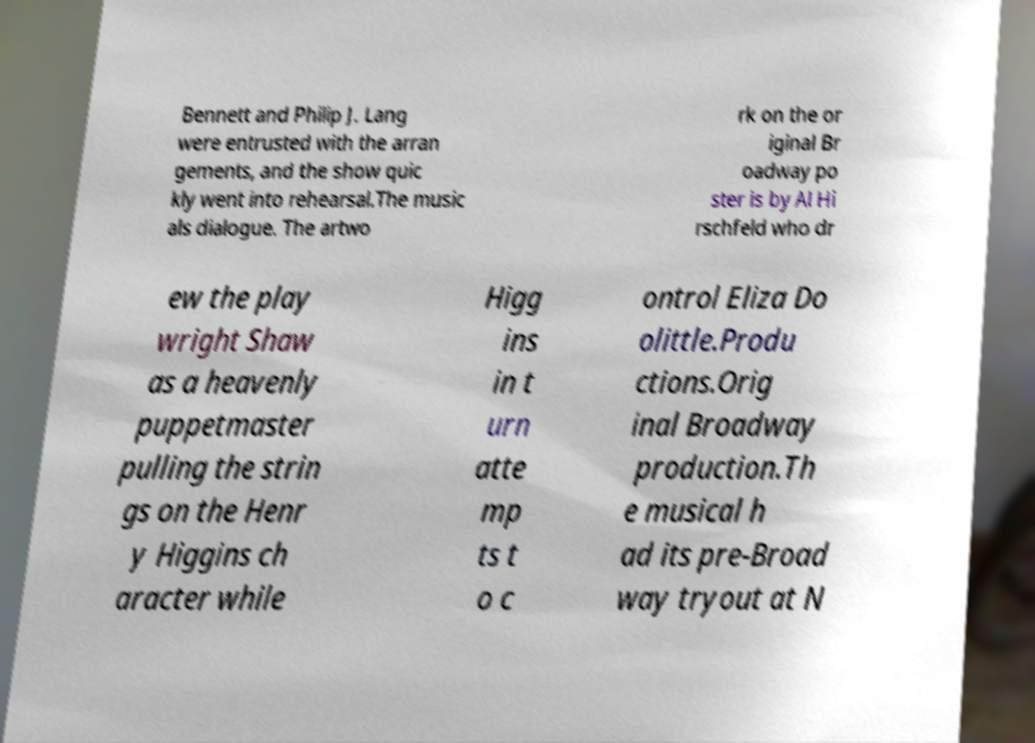Please read and relay the text visible in this image. What does it say? Bennett and Philip J. Lang were entrusted with the arran gements, and the show quic kly went into rehearsal.The music als dialogue. The artwo rk on the or iginal Br oadway po ster is by Al Hi rschfeld who dr ew the play wright Shaw as a heavenly puppetmaster pulling the strin gs on the Henr y Higgins ch aracter while Higg ins in t urn atte mp ts t o c ontrol Eliza Do olittle.Produ ctions.Orig inal Broadway production.Th e musical h ad its pre-Broad way tryout at N 